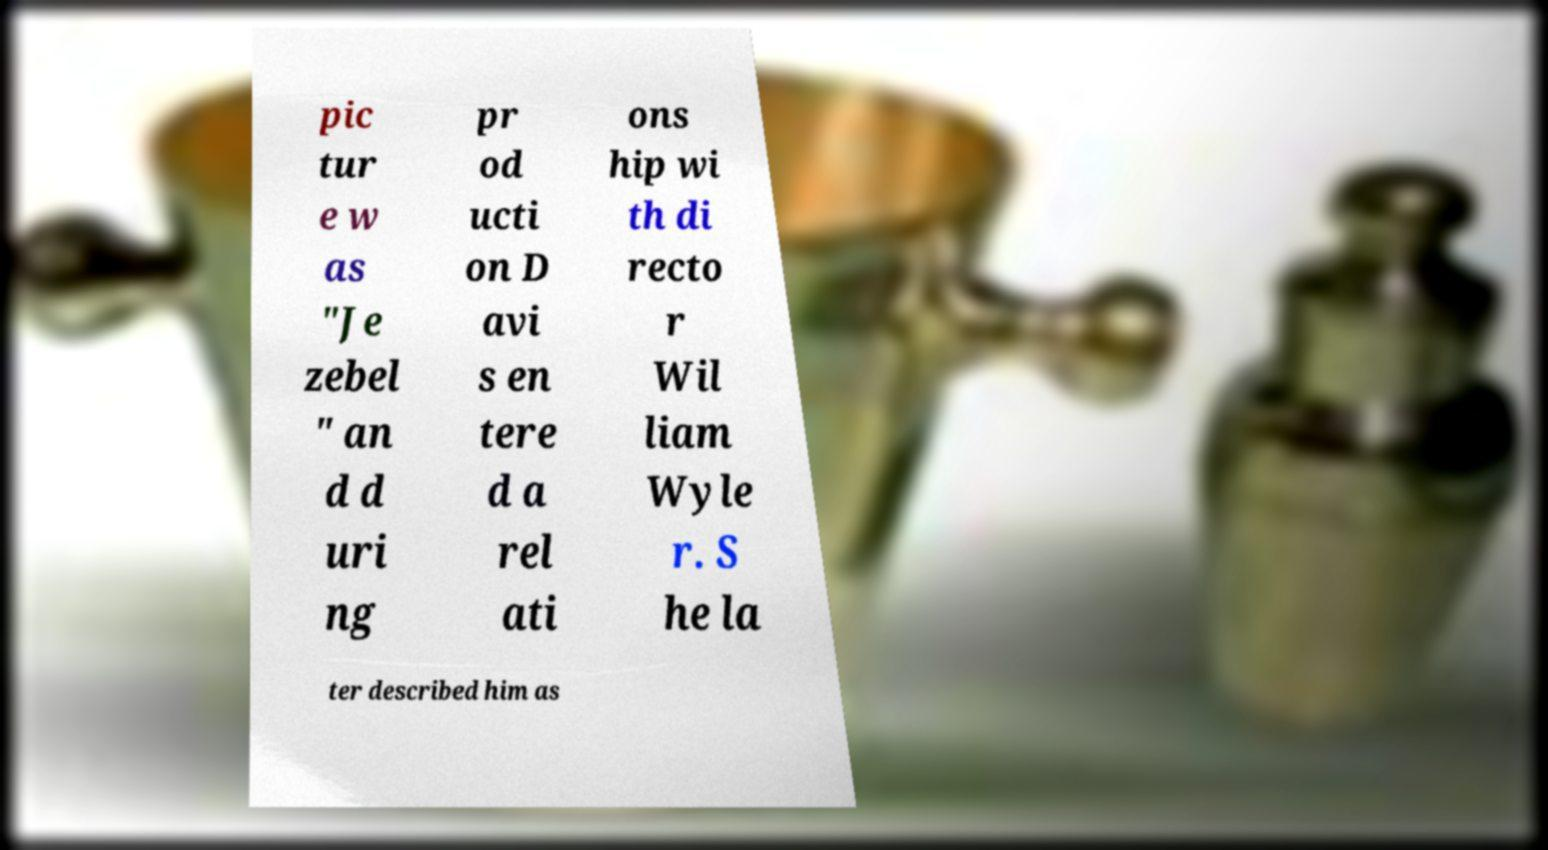Please read and relay the text visible in this image. What does it say? pic tur e w as "Je zebel " an d d uri ng pr od ucti on D avi s en tere d a rel ati ons hip wi th di recto r Wil liam Wyle r. S he la ter described him as 